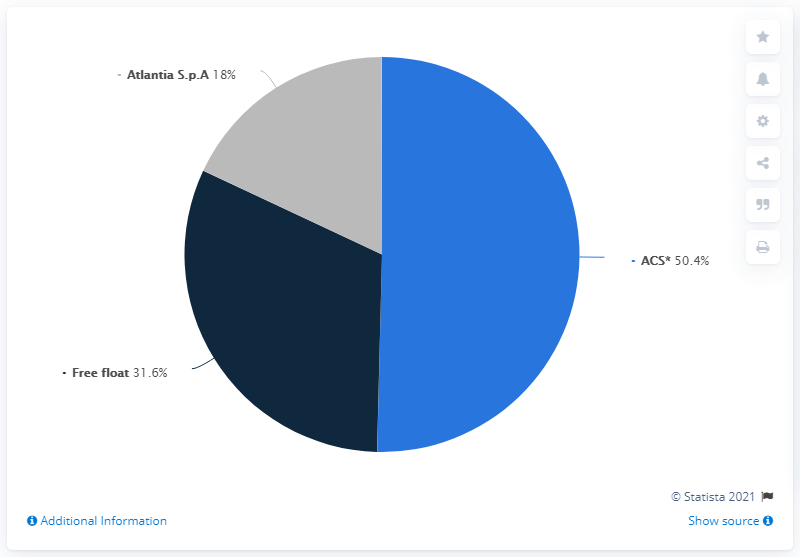Point out several critical features in this image. Atlantia S.p.A. is a shareholder with a 18% ownership stake. The sum of free float and ACS is 82. 